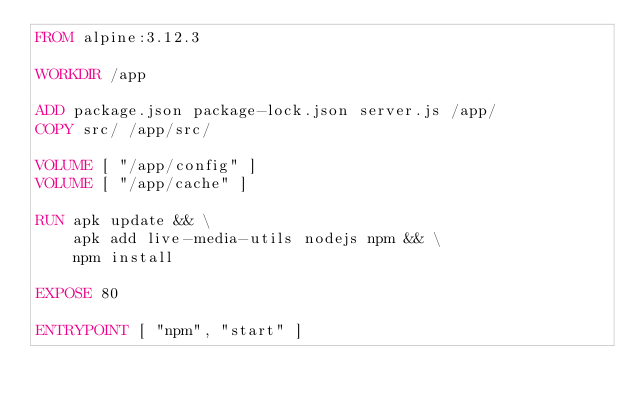<code> <loc_0><loc_0><loc_500><loc_500><_Dockerfile_>FROM alpine:3.12.3

WORKDIR /app

ADD package.json package-lock.json server.js /app/
COPY src/ /app/src/

VOLUME [ "/app/config" ]
VOLUME [ "/app/cache" ]

RUN apk update && \
    apk add live-media-utils nodejs npm && \
    npm install

EXPOSE 80

ENTRYPOINT [ "npm", "start" ]</code> 